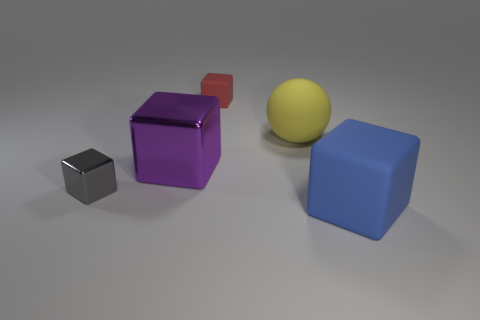Is there any other thing that has the same shape as the large yellow matte thing?
Provide a short and direct response. No. There is a rubber block that is behind the big blue cube; does it have the same size as the block that is on the left side of the large metal cube?
Keep it short and to the point. Yes. The big block in front of the large block to the left of the small red thing is what color?
Give a very brief answer. Blue. There is a purple object that is the same size as the ball; what is its material?
Provide a short and direct response. Metal. What number of metal objects are either large purple things or tiny gray cubes?
Offer a very short reply. 2. There is a block that is in front of the large purple metal object and left of the red block; what is its color?
Make the answer very short. Gray. There is a big blue matte object; what number of objects are on the left side of it?
Your answer should be very brief. 4. What is the blue block made of?
Offer a terse response. Rubber. What is the color of the large block that is right of the rubber cube behind the big block on the right side of the small red block?
Your answer should be compact. Blue. What number of gray things have the same size as the red matte block?
Your response must be concise. 1. 